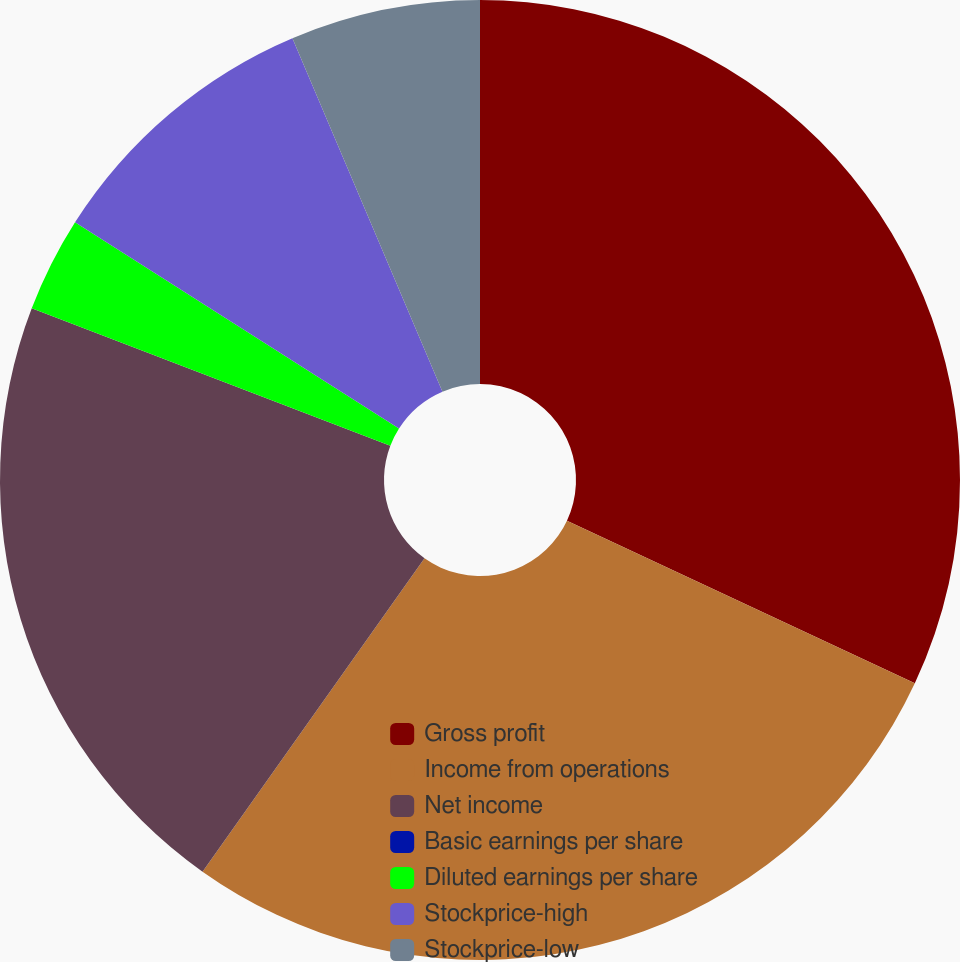<chart> <loc_0><loc_0><loc_500><loc_500><pie_chart><fcel>Gross profit<fcel>Income from operations<fcel>Net income<fcel>Basic earnings per share<fcel>Diluted earnings per share<fcel>Stockprice-high<fcel>Stockprice-low<nl><fcel>31.96%<fcel>27.85%<fcel>21.01%<fcel>0.0%<fcel>3.2%<fcel>9.59%<fcel>6.39%<nl></chart> 